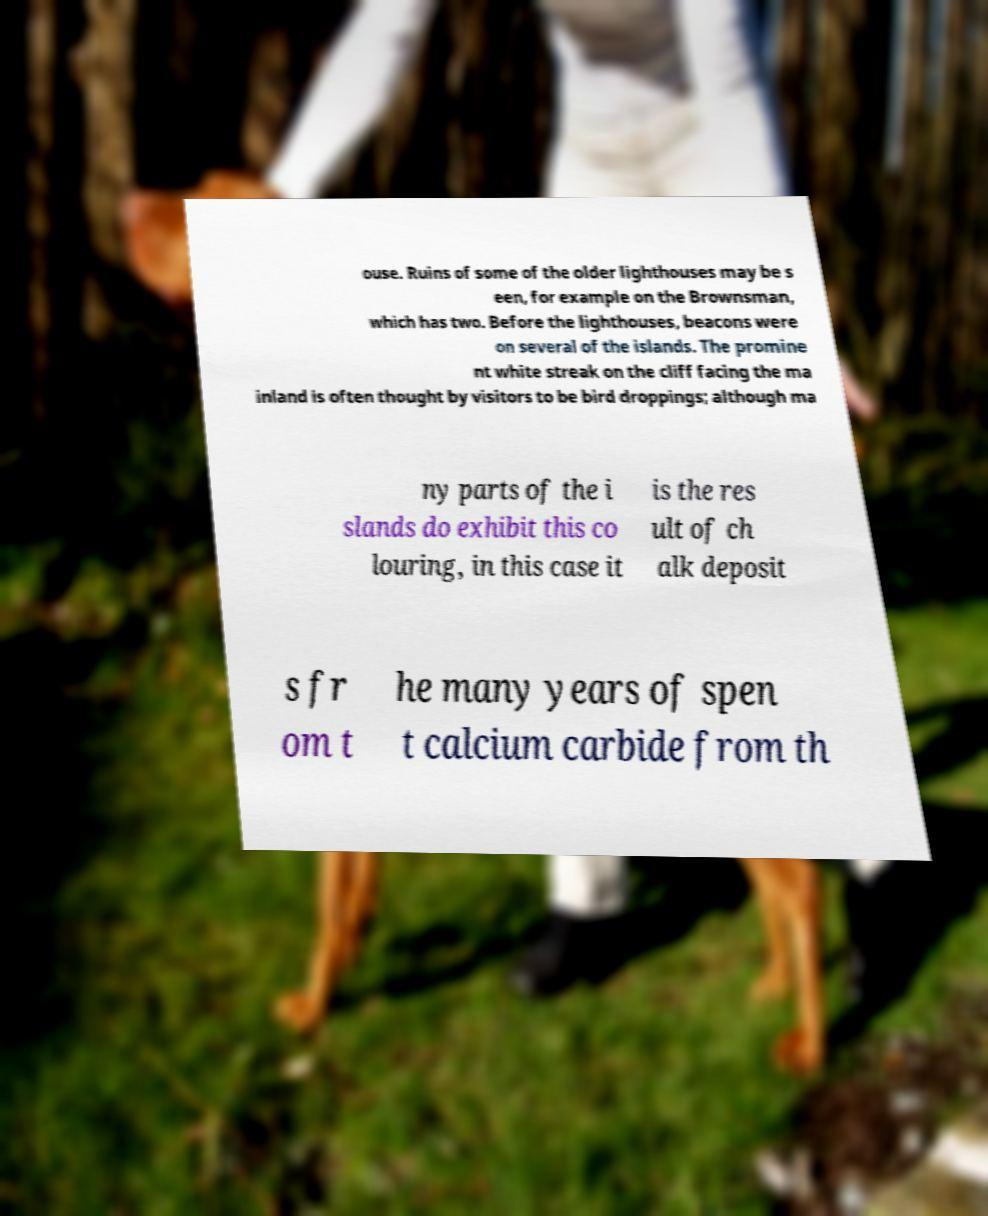Please identify and transcribe the text found in this image. ouse. Ruins of some of the older lighthouses may be s een, for example on the Brownsman, which has two. Before the lighthouses, beacons were on several of the islands. The promine nt white streak on the cliff facing the ma inland is often thought by visitors to be bird droppings; although ma ny parts of the i slands do exhibit this co louring, in this case it is the res ult of ch alk deposit s fr om t he many years of spen t calcium carbide from th 